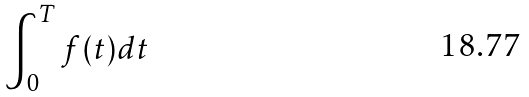<formula> <loc_0><loc_0><loc_500><loc_500>\int _ { 0 } ^ { T } f ( t ) d t</formula> 